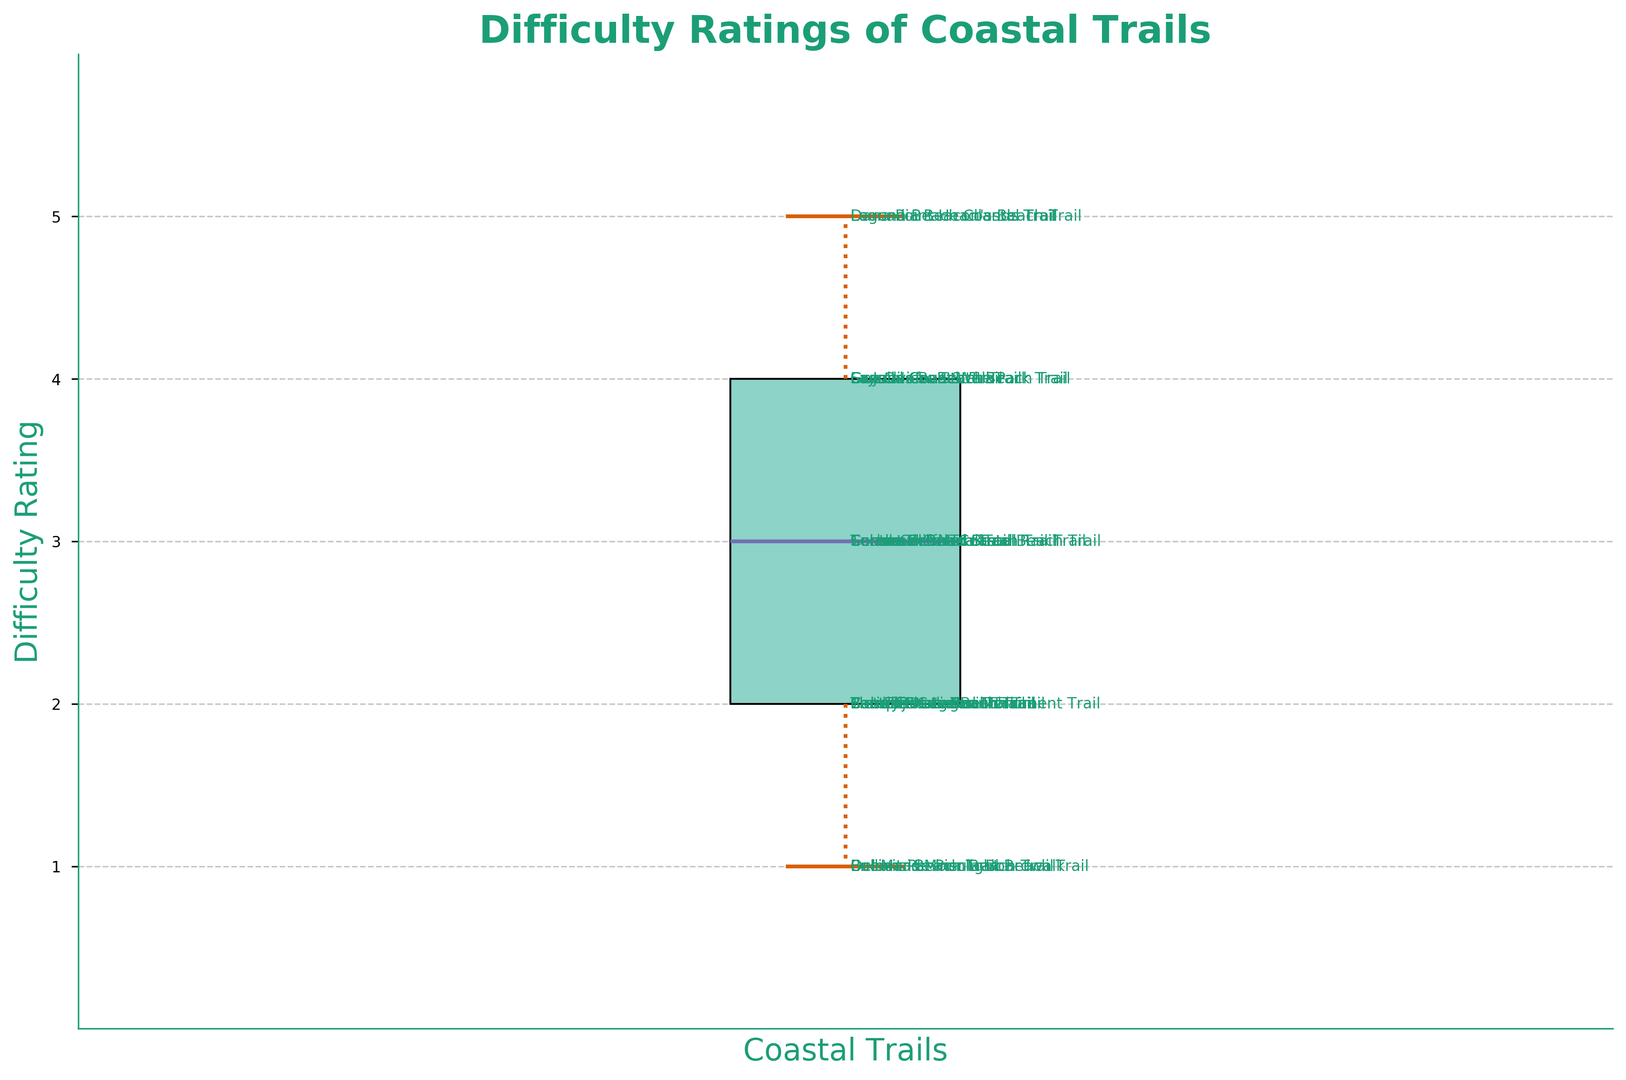What is the median difficulty rating for the coastal trails? To find the median difficulty rating, we need to locate the central value in the sorted list of all ratings. Since the ratings are 1, 1, 1, 1, 2, 2, 2, 2, 2, 2, 2, 2, 3, 3, 3, 3, 3, 4, 4, 4, 4, 4, 5, 5, the median rating is the middle number. With 25 ratings, the middle value is the 13th, which is 3.
Answer: 3 Which trail has the highest difficulty rating and what is it? To identify the highest difficulty rating, look for the maximum value represented by the top whisker or outliers. The longest whisker extends to 5, indicating the highest rating. The trails with this rating are Leucadia Beacon's Beach Trail, Dana Point Headlands Trail, and Laguna Beach Coastal Trail.
Answer: Leucadia Beacon's Beach Trail, Dana Point Headlands Trail, Laguna Beach Coastal Trail How many trails have a difficulty rating less than or equal to 2? Count the number of individual data points that are at or below the 2 mark on the y-axis. There are 10 trails with ratings of 1 and 8 trails with ratings of 2. Summing these, we have 10 + 8 = 18 trails.
Answer: 18 Out of all the trails, what is the range of difficulty ratings? The range is calculated by subtracting the minimum value from the maximum value. The minimum value is 1, and the maximum value is 5. Therefore, the range is 5 - 1 = 4.
Answer: 4 What is the most common difficulty rating among the coastal trails? The most common difficulty rating (mode) can be observed by looking at where the box plot is widest (densest). Here, the most frequent rating appears to be 2, as it is the middle point of the widest segment of the box plot.
Answer: 2 Which trail has the lowest difficulty rating and what is it? The lowest difficulty rating can be identified by the lowest point on the whisker. This is 1. Trails such as Del Mar Beach Trail, Oceanside Pier Beach Trail, Encinitas Moonlight Beach Trail, Balboa Peninsula Boardwalk have a rating of 1.
Answer: Del Mar Beach Trail, Oceanside Pier Beach Trail, Encinitas Moonlight Beach Trail, Balboa Peninsula Boardwalk How many trails have a difficulty rating of 3? We count how many data points are positioned at the 3 mark on the y-axis. There are 6 trails with a rating of 3.
Answer: 6 